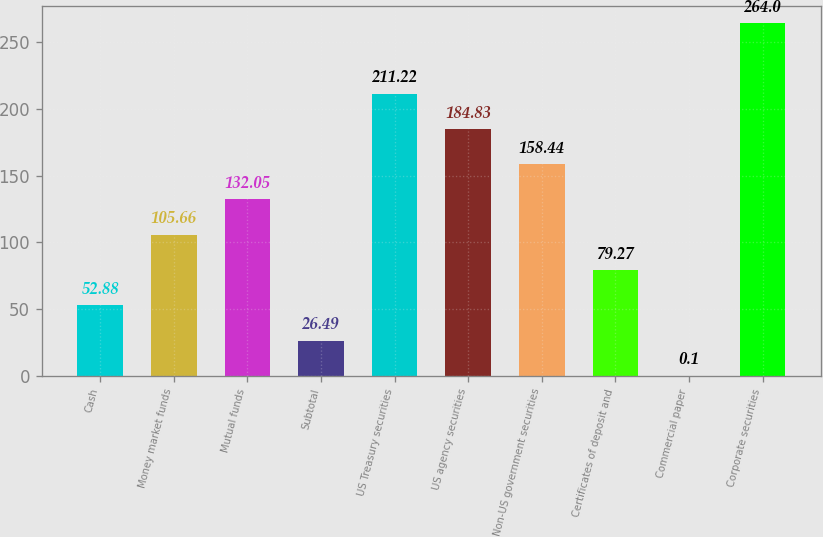<chart> <loc_0><loc_0><loc_500><loc_500><bar_chart><fcel>Cash<fcel>Money market funds<fcel>Mutual funds<fcel>Subtotal<fcel>US Treasury securities<fcel>US agency securities<fcel>Non-US government securities<fcel>Certificates of deposit and<fcel>Commercial paper<fcel>Corporate securities<nl><fcel>52.88<fcel>105.66<fcel>132.05<fcel>26.49<fcel>211.22<fcel>184.83<fcel>158.44<fcel>79.27<fcel>0.1<fcel>264<nl></chart> 